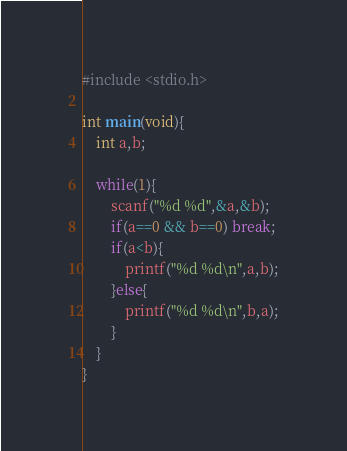Convert code to text. <code><loc_0><loc_0><loc_500><loc_500><_C_>#include <stdio.h>

int main(void){
    int a,b;
    
    while(1){
        scanf("%d %d",&a,&b);
        if(a==0 && b==0) break;
        if(a<b){
            printf("%d %d\n",a,b);
        }else{
            printf("%d %d\n",b,a);
        }
    }
}
</code> 